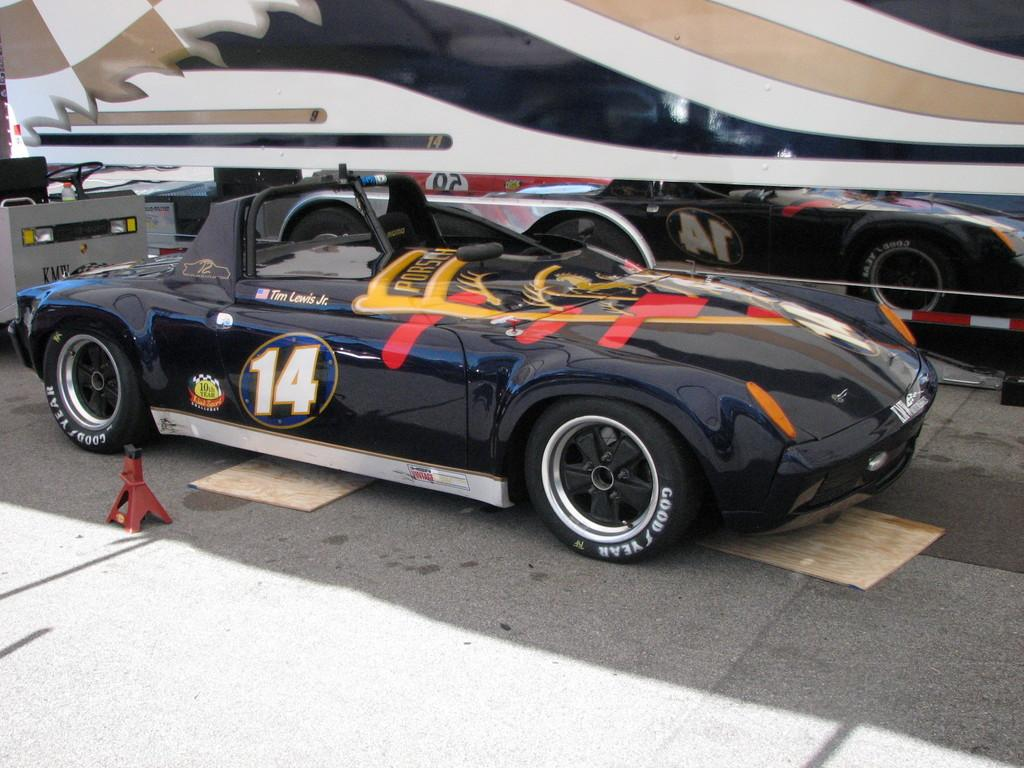<image>
Describe the image concisely. A black racing car with the number 14 on its door. 